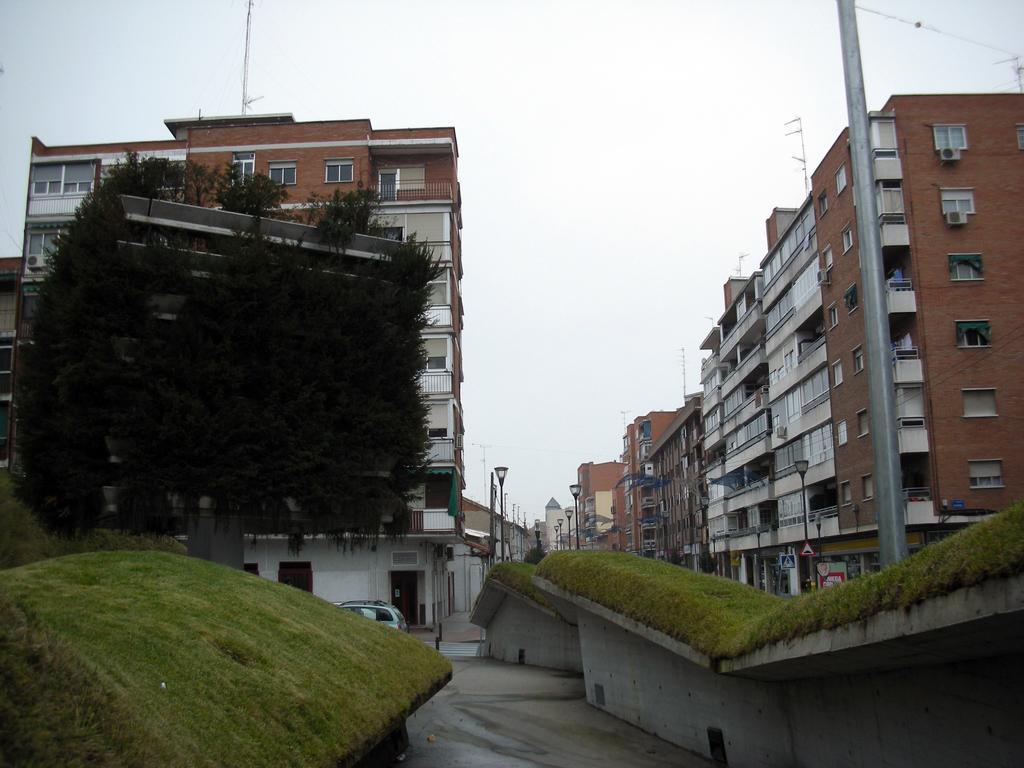Describe this image in one or two sentences. In this image I can see few buildings, windows, poles, trees, light poles, sky and the vehicle on the road. 